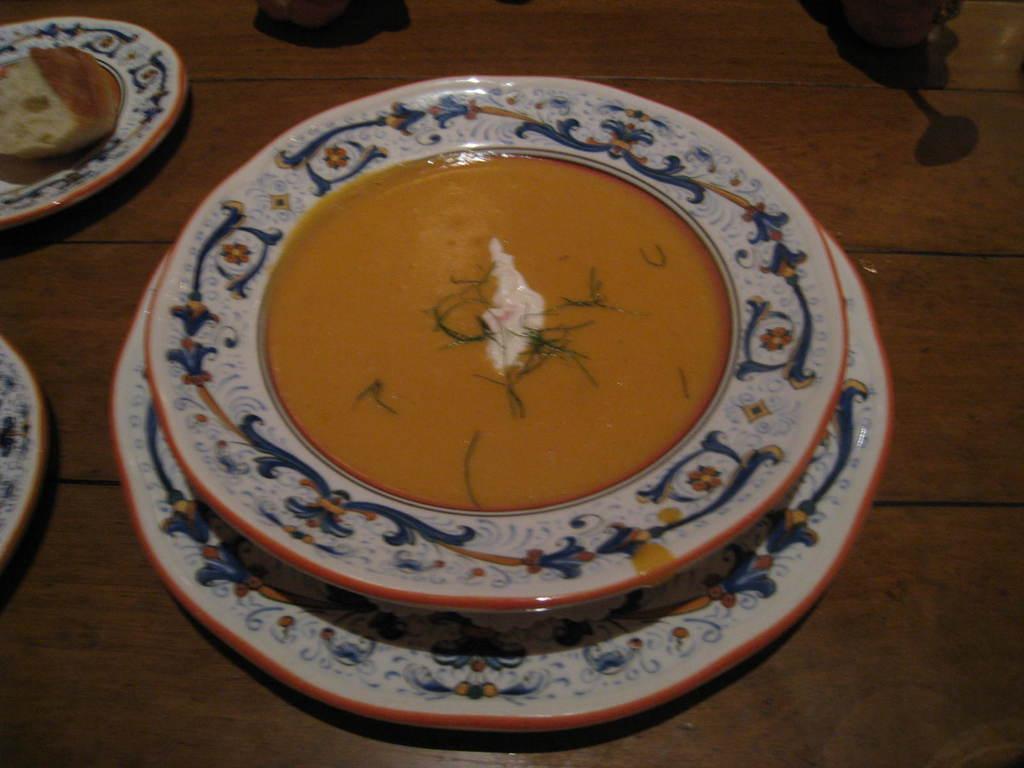Describe this image in one or two sentences. In this picture we can see there are plates on a wooden object and on the plates there are some food items. 